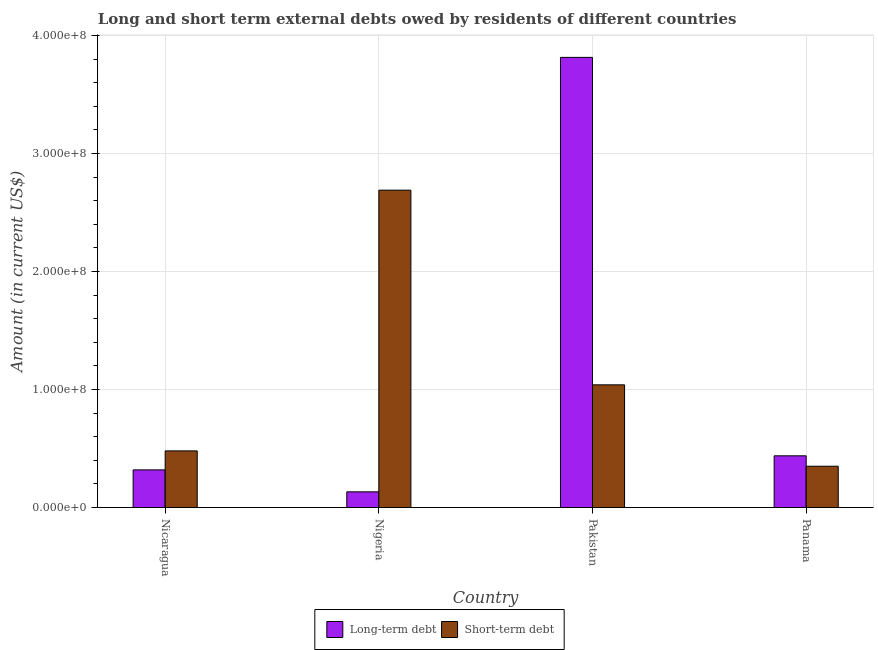How many groups of bars are there?
Your answer should be compact. 4. How many bars are there on the 3rd tick from the left?
Offer a very short reply. 2. How many bars are there on the 4th tick from the right?
Provide a short and direct response. 2. What is the label of the 4th group of bars from the left?
Keep it short and to the point. Panama. What is the long-term debts owed by residents in Nigeria?
Offer a terse response. 1.33e+07. Across all countries, what is the maximum long-term debts owed by residents?
Provide a short and direct response. 3.82e+08. Across all countries, what is the minimum short-term debts owed by residents?
Ensure brevity in your answer.  3.50e+07. In which country was the short-term debts owed by residents maximum?
Your answer should be very brief. Nigeria. In which country was the long-term debts owed by residents minimum?
Offer a terse response. Nigeria. What is the total short-term debts owed by residents in the graph?
Keep it short and to the point. 4.56e+08. What is the difference between the short-term debts owed by residents in Nicaragua and that in Pakistan?
Offer a terse response. -5.60e+07. What is the difference between the long-term debts owed by residents in Pakistan and the short-term debts owed by residents in Nigeria?
Keep it short and to the point. 1.13e+08. What is the average long-term debts owed by residents per country?
Offer a terse response. 1.18e+08. What is the difference between the short-term debts owed by residents and long-term debts owed by residents in Nicaragua?
Give a very brief answer. 1.61e+07. What is the ratio of the short-term debts owed by residents in Nigeria to that in Panama?
Your answer should be very brief. 7.69. Is the difference between the long-term debts owed by residents in Nigeria and Pakistan greater than the difference between the short-term debts owed by residents in Nigeria and Pakistan?
Offer a terse response. No. What is the difference between the highest and the second highest long-term debts owed by residents?
Your response must be concise. 3.38e+08. What is the difference between the highest and the lowest long-term debts owed by residents?
Provide a succinct answer. 3.68e+08. In how many countries, is the short-term debts owed by residents greater than the average short-term debts owed by residents taken over all countries?
Your answer should be very brief. 1. What does the 1st bar from the left in Nigeria represents?
Offer a terse response. Long-term debt. What does the 2nd bar from the right in Panama represents?
Provide a succinct answer. Long-term debt. How many bars are there?
Keep it short and to the point. 8. Are all the bars in the graph horizontal?
Give a very brief answer. No. How many countries are there in the graph?
Your answer should be very brief. 4. What is the difference between two consecutive major ticks on the Y-axis?
Your response must be concise. 1.00e+08. How are the legend labels stacked?
Your answer should be very brief. Horizontal. What is the title of the graph?
Provide a succinct answer. Long and short term external debts owed by residents of different countries. Does "% of GNI" appear as one of the legend labels in the graph?
Your answer should be very brief. No. What is the label or title of the X-axis?
Offer a very short reply. Country. What is the label or title of the Y-axis?
Keep it short and to the point. Amount (in current US$). What is the Amount (in current US$) of Long-term debt in Nicaragua?
Your answer should be very brief. 3.19e+07. What is the Amount (in current US$) of Short-term debt in Nicaragua?
Your response must be concise. 4.80e+07. What is the Amount (in current US$) in Long-term debt in Nigeria?
Make the answer very short. 1.33e+07. What is the Amount (in current US$) of Short-term debt in Nigeria?
Provide a succinct answer. 2.69e+08. What is the Amount (in current US$) of Long-term debt in Pakistan?
Provide a succinct answer. 3.82e+08. What is the Amount (in current US$) of Short-term debt in Pakistan?
Make the answer very short. 1.04e+08. What is the Amount (in current US$) of Long-term debt in Panama?
Keep it short and to the point. 4.38e+07. What is the Amount (in current US$) in Short-term debt in Panama?
Your answer should be very brief. 3.50e+07. Across all countries, what is the maximum Amount (in current US$) in Long-term debt?
Offer a very short reply. 3.82e+08. Across all countries, what is the maximum Amount (in current US$) of Short-term debt?
Provide a short and direct response. 2.69e+08. Across all countries, what is the minimum Amount (in current US$) of Long-term debt?
Your answer should be compact. 1.33e+07. Across all countries, what is the minimum Amount (in current US$) in Short-term debt?
Provide a short and direct response. 3.50e+07. What is the total Amount (in current US$) of Long-term debt in the graph?
Ensure brevity in your answer.  4.71e+08. What is the total Amount (in current US$) of Short-term debt in the graph?
Give a very brief answer. 4.56e+08. What is the difference between the Amount (in current US$) of Long-term debt in Nicaragua and that in Nigeria?
Your answer should be very brief. 1.86e+07. What is the difference between the Amount (in current US$) in Short-term debt in Nicaragua and that in Nigeria?
Your answer should be very brief. -2.21e+08. What is the difference between the Amount (in current US$) in Long-term debt in Nicaragua and that in Pakistan?
Your answer should be very brief. -3.50e+08. What is the difference between the Amount (in current US$) in Short-term debt in Nicaragua and that in Pakistan?
Offer a terse response. -5.60e+07. What is the difference between the Amount (in current US$) of Long-term debt in Nicaragua and that in Panama?
Your response must be concise. -1.19e+07. What is the difference between the Amount (in current US$) of Short-term debt in Nicaragua and that in Panama?
Keep it short and to the point. 1.30e+07. What is the difference between the Amount (in current US$) of Long-term debt in Nigeria and that in Pakistan?
Keep it short and to the point. -3.68e+08. What is the difference between the Amount (in current US$) in Short-term debt in Nigeria and that in Pakistan?
Ensure brevity in your answer.  1.65e+08. What is the difference between the Amount (in current US$) of Long-term debt in Nigeria and that in Panama?
Offer a very short reply. -3.05e+07. What is the difference between the Amount (in current US$) in Short-term debt in Nigeria and that in Panama?
Ensure brevity in your answer.  2.34e+08. What is the difference between the Amount (in current US$) in Long-term debt in Pakistan and that in Panama?
Give a very brief answer. 3.38e+08. What is the difference between the Amount (in current US$) of Short-term debt in Pakistan and that in Panama?
Your response must be concise. 6.90e+07. What is the difference between the Amount (in current US$) in Long-term debt in Nicaragua and the Amount (in current US$) in Short-term debt in Nigeria?
Offer a terse response. -2.37e+08. What is the difference between the Amount (in current US$) in Long-term debt in Nicaragua and the Amount (in current US$) in Short-term debt in Pakistan?
Your answer should be very brief. -7.21e+07. What is the difference between the Amount (in current US$) of Long-term debt in Nicaragua and the Amount (in current US$) of Short-term debt in Panama?
Your answer should be compact. -3.10e+06. What is the difference between the Amount (in current US$) in Long-term debt in Nigeria and the Amount (in current US$) in Short-term debt in Pakistan?
Ensure brevity in your answer.  -9.07e+07. What is the difference between the Amount (in current US$) of Long-term debt in Nigeria and the Amount (in current US$) of Short-term debt in Panama?
Your answer should be very brief. -2.17e+07. What is the difference between the Amount (in current US$) of Long-term debt in Pakistan and the Amount (in current US$) of Short-term debt in Panama?
Provide a succinct answer. 3.47e+08. What is the average Amount (in current US$) in Long-term debt per country?
Give a very brief answer. 1.18e+08. What is the average Amount (in current US$) in Short-term debt per country?
Offer a terse response. 1.14e+08. What is the difference between the Amount (in current US$) in Long-term debt and Amount (in current US$) in Short-term debt in Nicaragua?
Provide a succinct answer. -1.61e+07. What is the difference between the Amount (in current US$) of Long-term debt and Amount (in current US$) of Short-term debt in Nigeria?
Give a very brief answer. -2.56e+08. What is the difference between the Amount (in current US$) of Long-term debt and Amount (in current US$) of Short-term debt in Pakistan?
Give a very brief answer. 2.78e+08. What is the difference between the Amount (in current US$) of Long-term debt and Amount (in current US$) of Short-term debt in Panama?
Offer a very short reply. 8.83e+06. What is the ratio of the Amount (in current US$) of Long-term debt in Nicaragua to that in Nigeria?
Provide a short and direct response. 2.4. What is the ratio of the Amount (in current US$) of Short-term debt in Nicaragua to that in Nigeria?
Give a very brief answer. 0.18. What is the ratio of the Amount (in current US$) in Long-term debt in Nicaragua to that in Pakistan?
Provide a succinct answer. 0.08. What is the ratio of the Amount (in current US$) in Short-term debt in Nicaragua to that in Pakistan?
Ensure brevity in your answer.  0.46. What is the ratio of the Amount (in current US$) in Long-term debt in Nicaragua to that in Panama?
Your response must be concise. 0.73. What is the ratio of the Amount (in current US$) of Short-term debt in Nicaragua to that in Panama?
Offer a very short reply. 1.37. What is the ratio of the Amount (in current US$) of Long-term debt in Nigeria to that in Pakistan?
Your answer should be very brief. 0.03. What is the ratio of the Amount (in current US$) of Short-term debt in Nigeria to that in Pakistan?
Offer a terse response. 2.59. What is the ratio of the Amount (in current US$) in Long-term debt in Nigeria to that in Panama?
Your answer should be compact. 0.3. What is the ratio of the Amount (in current US$) of Short-term debt in Nigeria to that in Panama?
Offer a very short reply. 7.69. What is the ratio of the Amount (in current US$) in Long-term debt in Pakistan to that in Panama?
Give a very brief answer. 8.7. What is the ratio of the Amount (in current US$) of Short-term debt in Pakistan to that in Panama?
Ensure brevity in your answer.  2.97. What is the difference between the highest and the second highest Amount (in current US$) of Long-term debt?
Offer a very short reply. 3.38e+08. What is the difference between the highest and the second highest Amount (in current US$) in Short-term debt?
Ensure brevity in your answer.  1.65e+08. What is the difference between the highest and the lowest Amount (in current US$) of Long-term debt?
Ensure brevity in your answer.  3.68e+08. What is the difference between the highest and the lowest Amount (in current US$) of Short-term debt?
Give a very brief answer. 2.34e+08. 